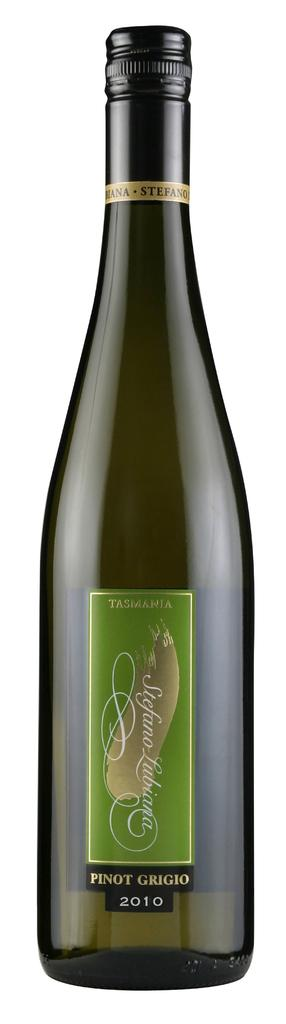<image>
Create a compact narrative representing the image presented. A green labeled bottle of Pinot Grigio branded alcohol. 